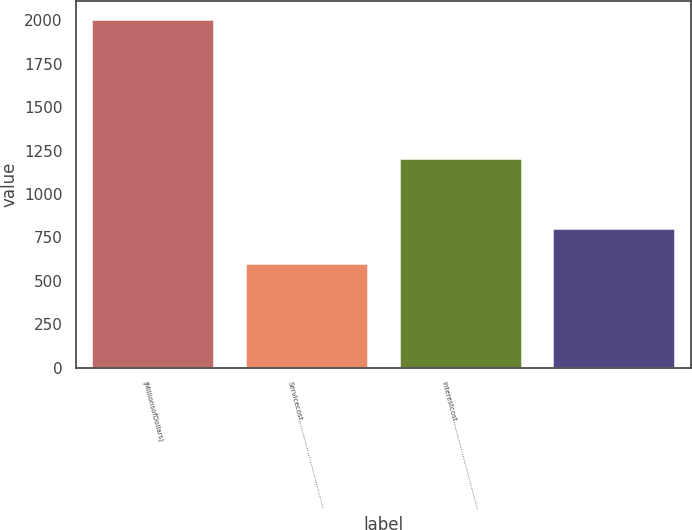<chart> <loc_0><loc_0><loc_500><loc_500><bar_chart><fcel>(MillionsofDollars)<fcel>Servicecost…………………………………<fcel>Interestcost…………………………………<fcel>Unnamed: 3<nl><fcel>2011<fcel>603.51<fcel>1206.72<fcel>804.58<nl></chart> 